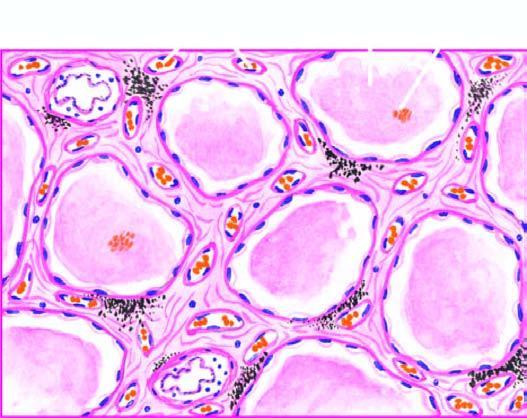do others contain eosinophilic, granular, homogeneous and pink proteinaceous oedema fluid along with some rbcs and inflammatory cells?
Answer the question using a single word or phrase. No 